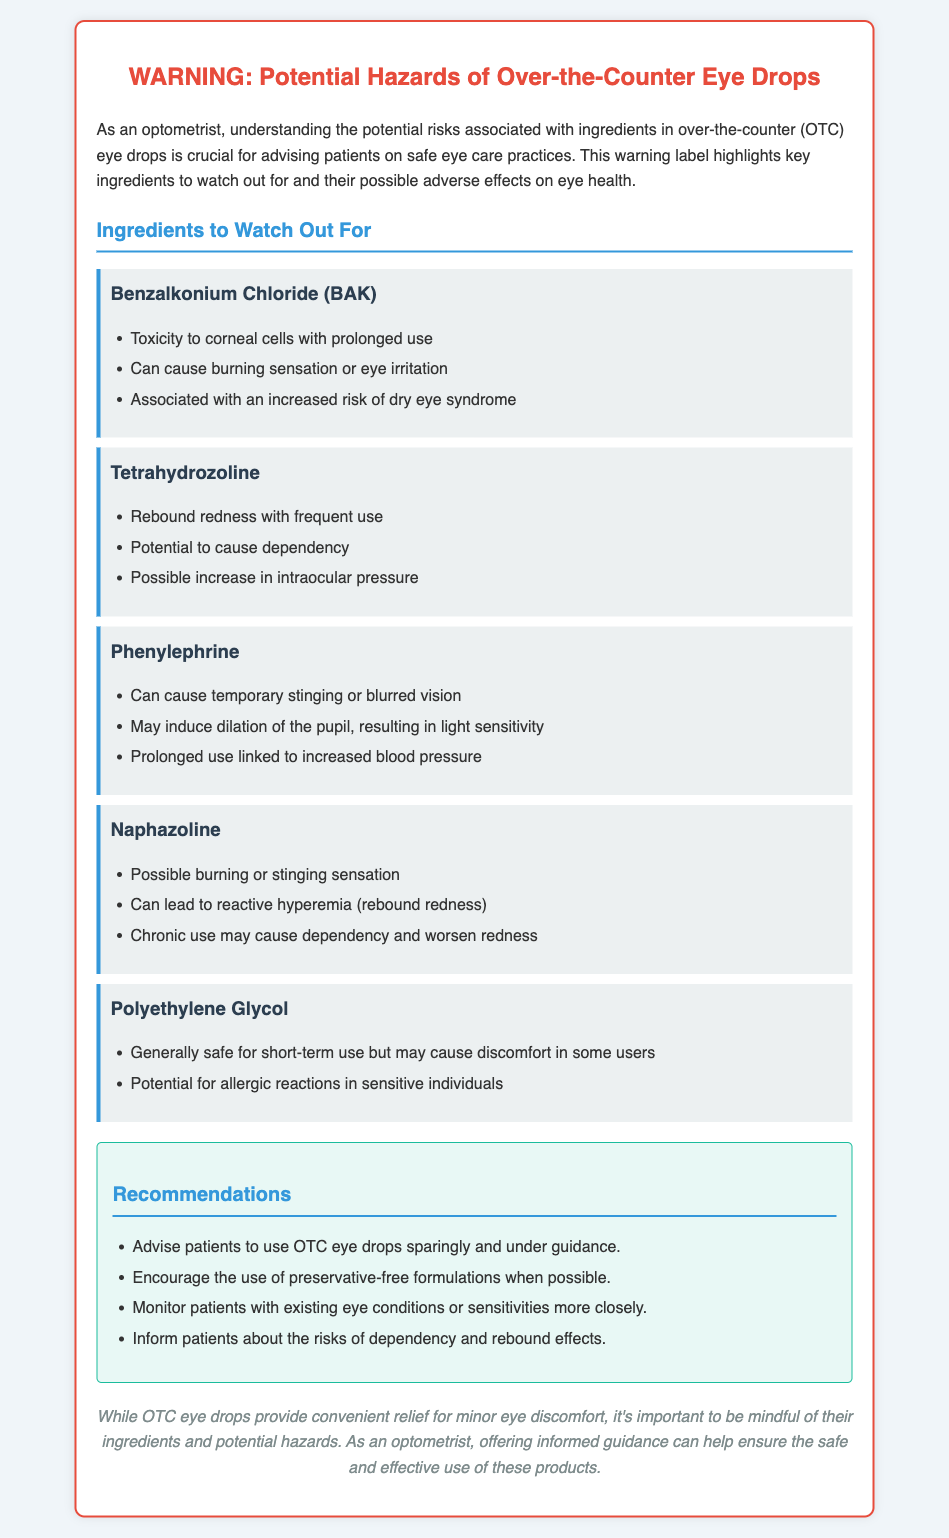What is the main topic of the warning label? The main topic of the warning label is the potential hazards of over-the-counter eye drops.
Answer: Potential hazards of over-the-counter eye drops What ingredient is associated with rebound redness? The ingredient known for causing rebound redness is Tetrahydrozoline and Naphazoline.
Answer: Tetrahydrozoline, Naphazoline What adverse effect is linked with Benzalkonium Chloride? Benzalkonium Chloride is linked to toxicity to corneal cells with prolonged use.
Answer: Toxicity to corneal cells How many recommendations are provided in the document? The document lists four recommendations for the use of OTC eye drops.
Answer: Four What is the risk associated with prolonged use of Phenylephrine? Prolonged use of Phenylephrine is linked to increased blood pressure.
Answer: Increased blood pressure What should be encouraged to use when possible? The document encourages the use of preservative-free formulations when possible.
Answer: Preservative-free formulations Which ingredient may cause discomfort in some users? Polyethylene Glycol may cause discomfort in some users.
Answer: Polyethylene Glycol What is advised for patients with existing eye conditions? The document advises to monitor patients with existing eye conditions or sensitivities more closely.
Answer: Monitor patients more closely 